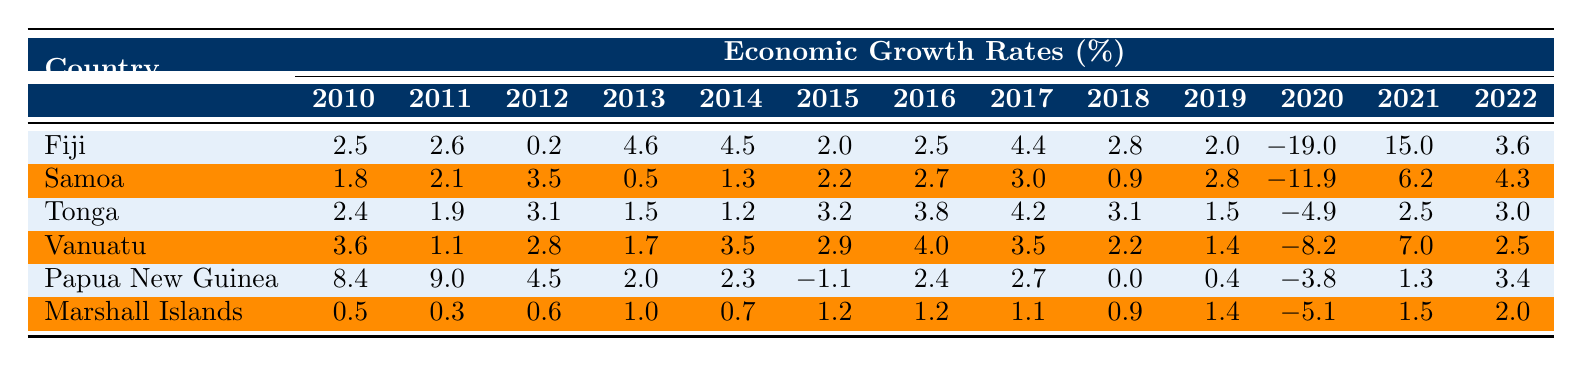What was Fiji's economic growth rate in 2020? The table shows Fiji's economic growth rate for 2020, which is listed as -19.0.
Answer: -19.0 What is the highest economic growth rate recorded by Papua New Guinea during the years 2010 to 2022? Looking through the data for Papua New Guinea, the highest value is 9.0, observed in 2011.
Answer: 9.0 Which country had the lowest economic growth rate in 2020? By examining the 2020 values for each country, Fiji had -19.0 and Samoa had -11.9, making Fiji the lowest.
Answer: Fiji What was the average economic growth rate of Samoa from 2010 to 2022? The rates for Samoa are 1.8, 2.1, 3.5, 0.5, 1.3, 2.2, 2.7, 3.0, 0.9, 2.8, -11.9, 6.2, and 4.3. Summing these gives  19.5, and dividing by 13 gives an average of approximately 1.5.
Answer: 1.5 Did Vanuatu experience a negative economic growth rate in 2021? The table indicates Vanuatu’s growth rate for 2021 is 7.0, which is positive. Therefore, the statement is false.
Answer: No What was the difference between the economic growth rates of Tonga in 2018 and 2020? Tonga's rates in 2018 and 2020 are 3.1 and -4.9, respectively. The difference is calculated as 3.1 - (-4.9) = 3.1 + 4.9 = 8.0.
Answer: 8.0 Between which two years did Fiji see its highest economic growth rate? Reviewing Fiji's rates, the highest figure is 15.0 in 2021 after a drop to -19.0 in 2020, making the years 2020 to 2021 the highest increase.
Answer: 2020 to 2021 Which country had consistently positive growth rates from 2010 to 2019? By checking the growth rates for each country during these years, only Samoa had consistently positive values, with no negatives in 2010-2019.
Answer: Samoa What trend can be observed for Marshall Islands' economic growth rates from 2010 to 2019? The data for Marshall Islands reveals a mix of low positive growth rates and one negative rate in 2020, suggesting stagnant growth until 2021 where it shows slight increase again.
Answer: Mixed low growth In what year did Papua New Guinea first experience a negative economic growth rate? Reviewing Papua New Guinea's data, the first negative growth rate occurs in 2015 with a value of -1.1.
Answer: 2015 